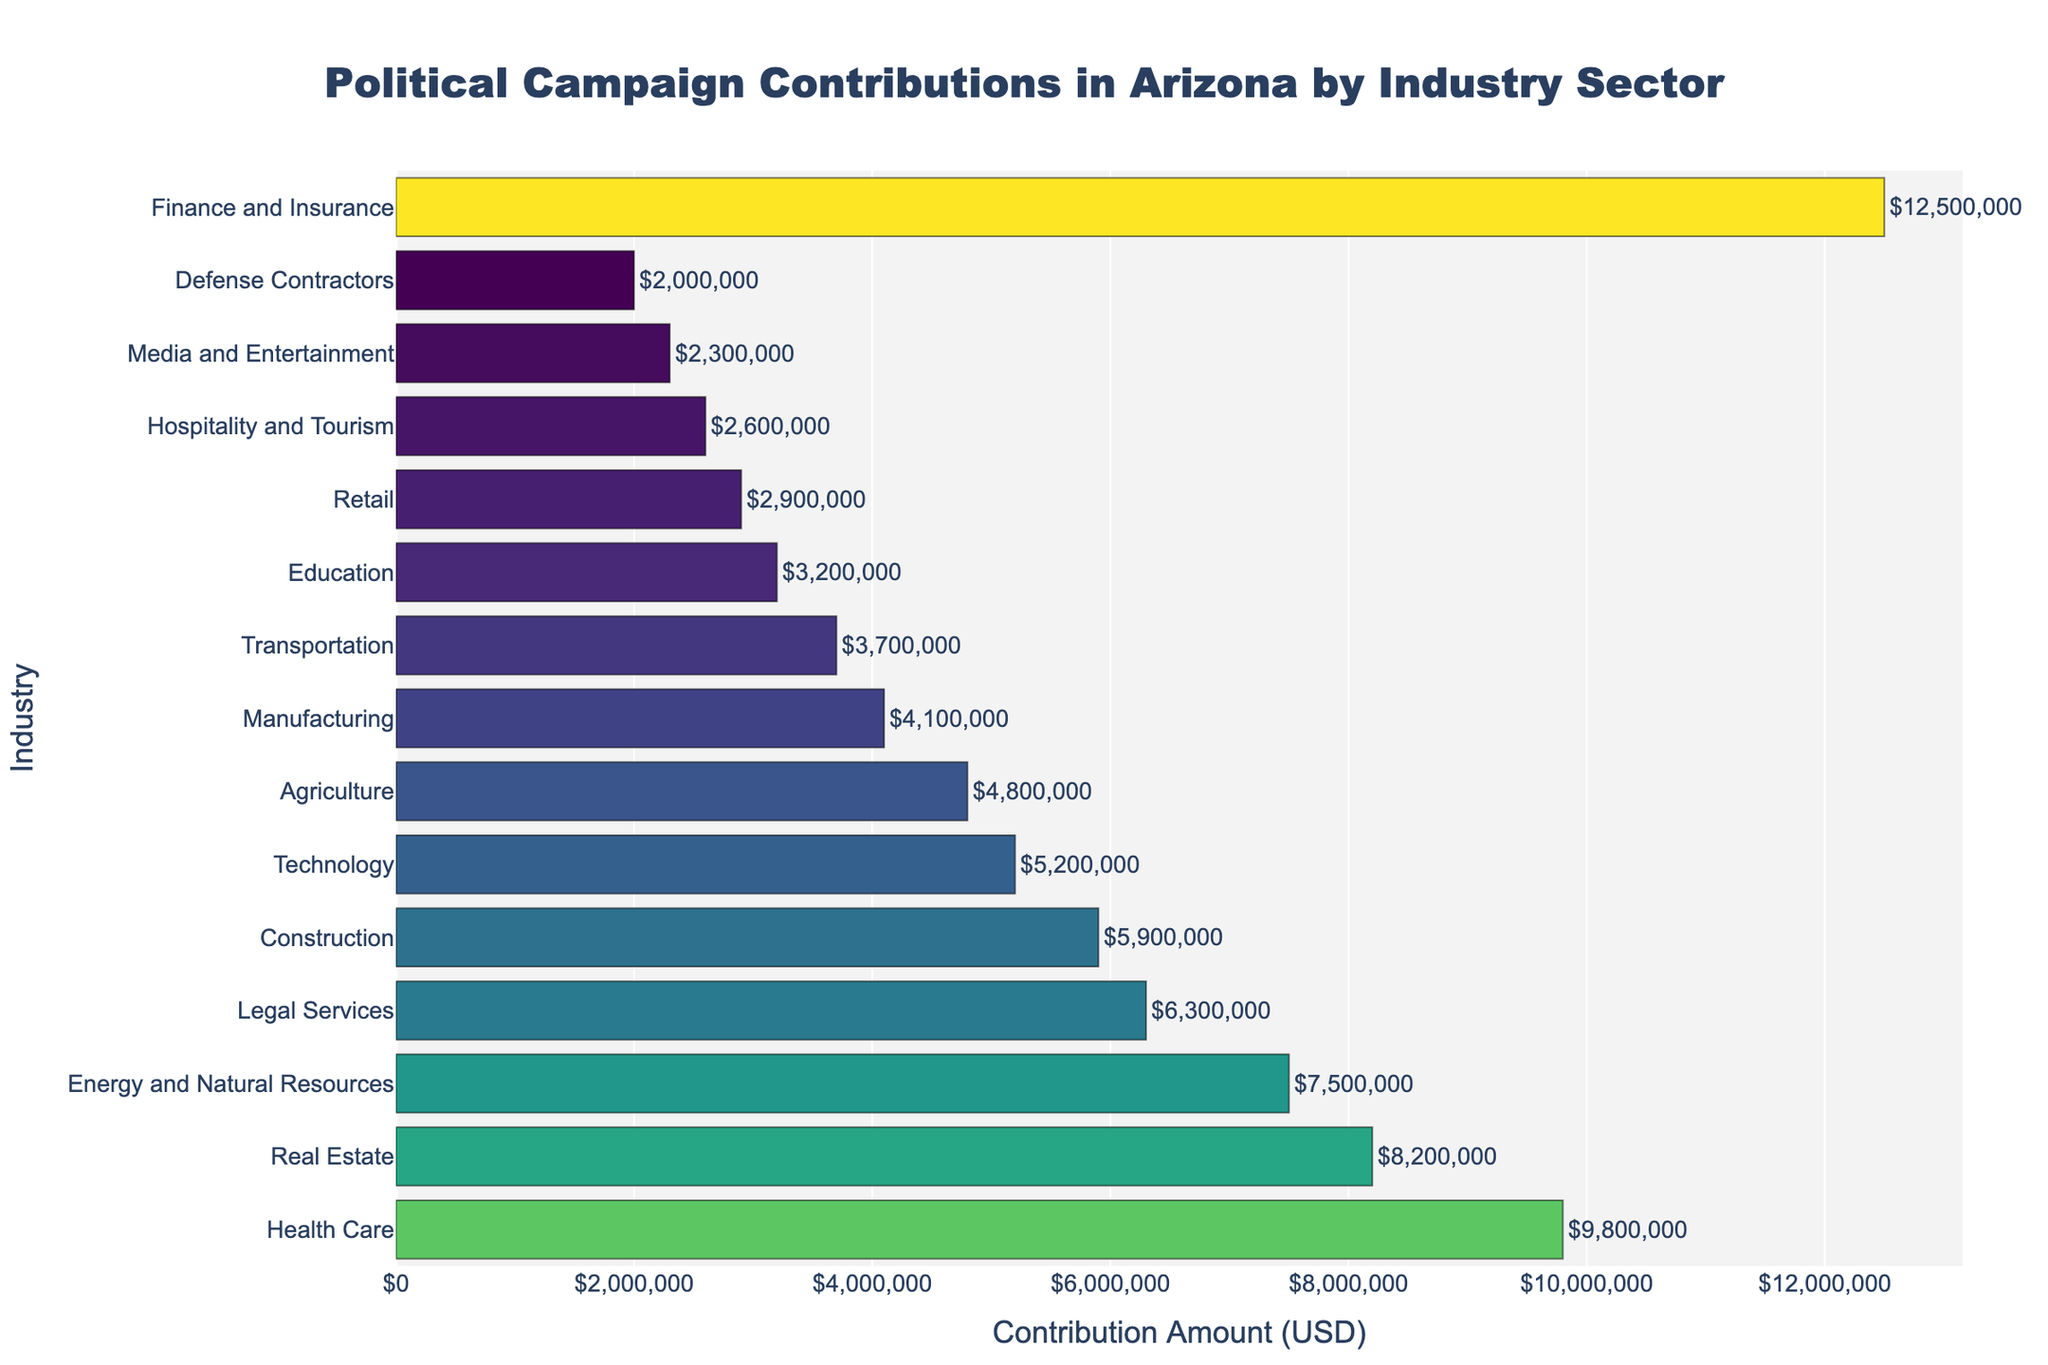Which industry has the highest political campaign contributions? The tallest bar will indicate the industry with the highest contributions. The bar for the Finance and Insurance industry is the highest.
Answer: Finance and Insurance How much did the Technology sector contribute to political campaigns? Locate the bar labeled "Technology" and read the value at the end of the bar. The contribution amount for Technology is $5,200,000.
Answer: $5,200,000 Which two sectors contributed the least? Identify the two shortest bars in the chart. The bars for Defense Contractors and Media and Entertainment are the shortest.
Answer: Defense Contractors and Media and Entertainment What is the combined contribution from the Health Care and Real Estate sectors? Find and sum the contribution amounts for Health Care and Real Estate. Health Care contributed $9,800,000 and Real Estate contributed $8,200,000, so the combined amount is $9,800,000 + $8,200,000.
Answer: $18,000,000 How does the contribution from the Construction sector compare to the Manufacturing sector? Compare the lengths of the bars labeled "Construction" and "Manufacturing". The Construction sector contributed $5,900,000, which is higher than the $4,100,000 from the Manufacturing sector.
Answer: Construction is higher What is the difference in contributions between the highest and the lowest contributing industries? Subtract the contribution amount of the lowest industry (Defense Contractors, $2,000,000) from the highest industry (Finance and Insurance, $12,500,000). The difference is $12,500,000 - $2,000,000.
Answer: $10,500,000 Is the contribution from the Agriculture sector more or less than the Transportation sector? Compare the lengths of the bars labeled "Agriculture" and "Transportation". The Agriculture sector contributed $4,800,000, while the Transportation sector contributed $3,700,000.
Answer: More How much more did the Energy and Natural Resources sector contribute compared to the Retail sector? Find the contribution amounts for Energy and Natural Resources ($7,500,000) and Retail ($2,900,000) and subtract the latter from the former. The difference is $7,500,000 - $2,900,000.
Answer: $4,600,000 What is the average contribution amount across all sectors? Sum all the contribution amounts and divide by the number of sectors. The total is $125,000,000 and there are 15 sectors. The average is $125,000,000 / 15.
Answer: $8,333,333 